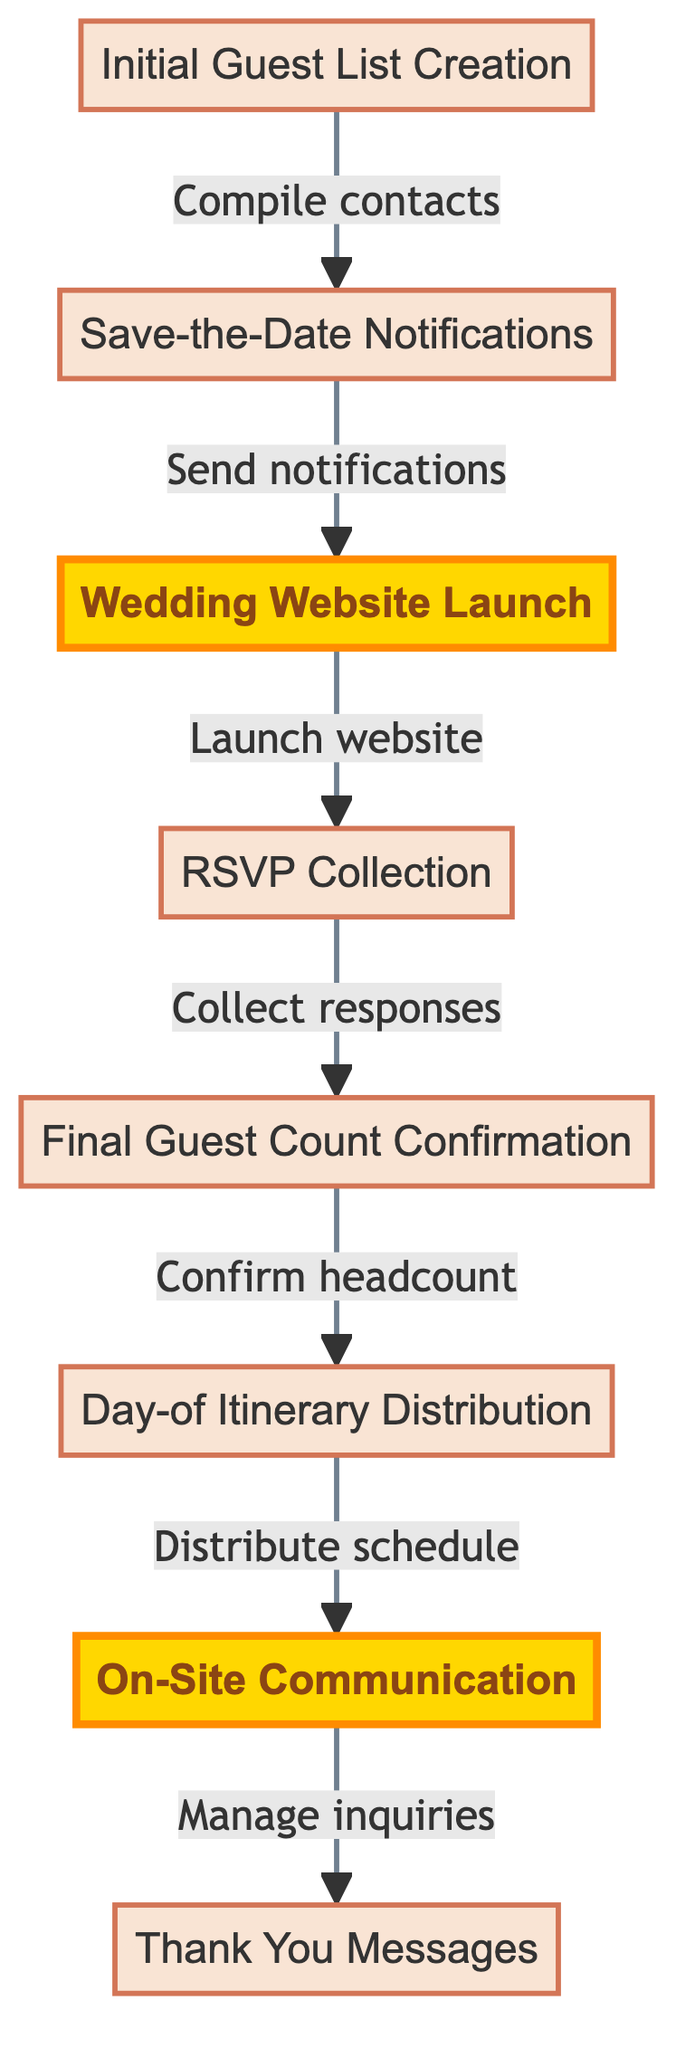What is the first step in the guest communication plan? The diagram indicates that the initial step is "Initial Guest List Creation." This is the starting point from which the other steps are derived.
Answer: Initial Guest List Creation How many nodes are in the flowchart? The diagram lists eight distinct elements or nodes which represent different steps in the guest communication plan.
Answer: 8 What is sent after the "Save-the-Date Notifications"? The next step after sending "Save-the-Date Notifications" is to "Wedding Website Launch," as indicated by the flow from node 2 to node 3.
Answer: Wedding Website Launch What happens after "RSVP Collection"? Following "RSVP Collection," the next action is "Final Guest Count Confirmation," as shown by the directed flow from node 4 to node 5.
Answer: Final Guest Count Confirmation Which step involves distributing a schedule? The step that involves distributing a detailed schedule is "Day-of Itinerary Distribution," which is indicated as occurring before the "On-Site Communication."
Answer: Day-of Itinerary Distribution What is a highlighted step in the diagram? The diagram highlights "Wedding Website Launch" and "On-Site Communication," indicating their significance within the guest communication plan.
Answer: Wedding Website Launch, On-Site Communication How many times is "Communication" mentioned in the flowchart? The term "Communication" appears twice, specifically in "On-Site Communication" and implicitly around other elements relating to guest notifications and engagement.
Answer: 2 What connects "Final Guest Count Confirmation" to "Day-of Itinerary Distribution"? The connection is made through a directed flow indicating that confirming the final headcount directly leads to the distribution of the day-of schedule, showing a logical sequence in the planning process.
Answer: Confirm headcount What action follows after the last step of the diagram? The last step listed in the flowchart is "Thank You Messages," which comes after the "On-Site Communication."
Answer: Thank You Messages 